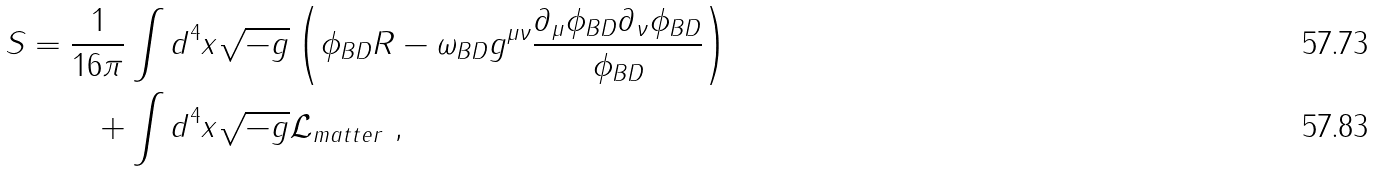Convert formula to latex. <formula><loc_0><loc_0><loc_500><loc_500>S = \frac { 1 } { 1 6 \pi } & \int d ^ { 4 } x \sqrt { - g } \left ( \phi _ { B D } R - \omega _ { B D } g ^ { \mu \nu } \frac { \partial _ { \mu } \phi _ { B D } \partial _ { \nu } \phi _ { B D } } { \phi _ { B D } } \right ) \\ + & \int d ^ { 4 } x \sqrt { - g } \mathcal { L } _ { m a t t e r } \ ,</formula> 